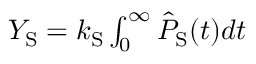Convert formula to latex. <formula><loc_0><loc_0><loc_500><loc_500>\begin{array} { r } { Y _ { S } = k _ { S } \int _ { 0 } ^ { \infty } \hat { P } _ { S } ( t ) d t } \end{array}</formula> 